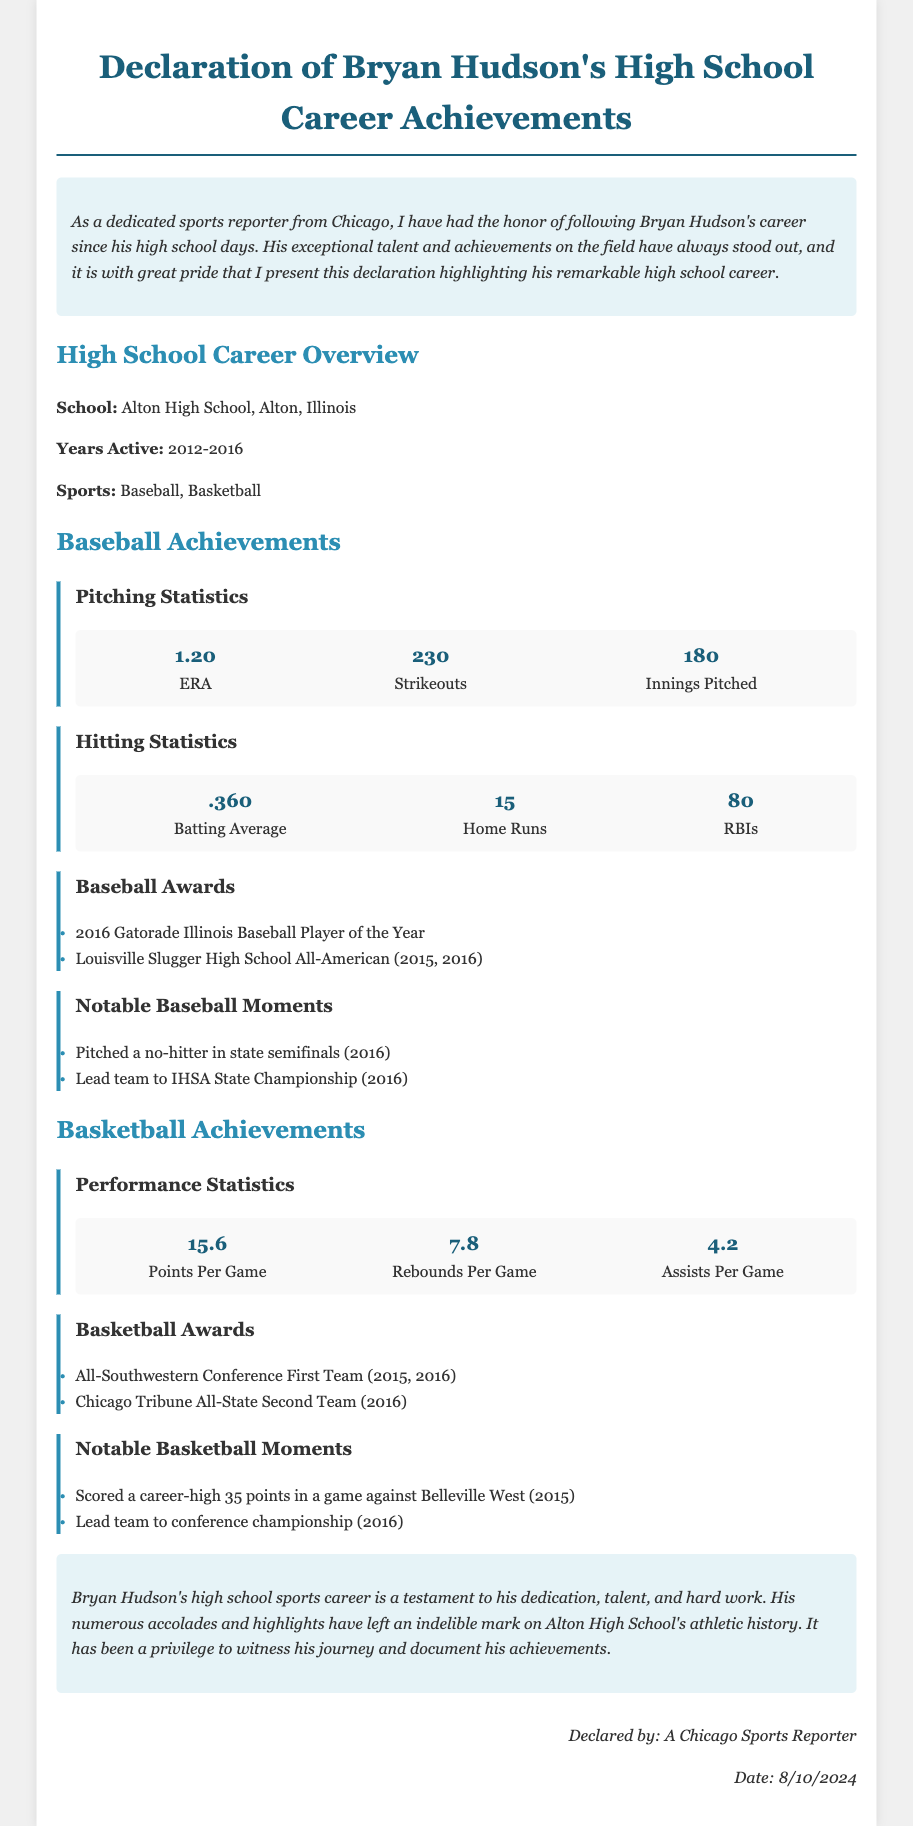What high school did Bryan Hudson attend? The document states that Bryan Hudson attended Alton High School in Alton, Illinois.
Answer: Alton High School What years was Bryan Hudson active in sports? The document mentions that Bryan Hudson was active from 2012 to 2016.
Answer: 2012-2016 What is Bryan Hudson's career ERA in baseball? The document provides Bryan Hudson's pitching statistics, which include an ERA of 1.20.
Answer: 1.20 How many home runs did Bryan Hudson hit during his high school baseball career? The document lists that Bryan Hudson hit 15 home runs.
Answer: 15 What was Bryan Hudson's average points per game in basketball? The document states that his points per game average was 15.6.
Answer: 15.6 Which award did Bryan Hudson receive in 2016 for baseball? The document mentions that he was the Gatorade Illinois Baseball Player of the Year in 2016.
Answer: 2016 Gatorade Illinois Baseball Player of the Year What notable basketball achievement did Hudson accomplish in 2015? The document notes he scored a career-high of 35 points in a game against Belleville West in 2015.
Answer: Scored a career-high 35 points What were the two sports Bryan Hudson played in high school? The document specifies that he played baseball and basketball in high school.
Answer: Baseball, Basketball How many strikeouts did Bryan Hudson achieve in baseball? The document indicates that he had 230 strikeouts during his high school baseball career.
Answer: 230 